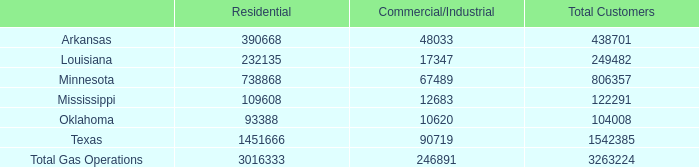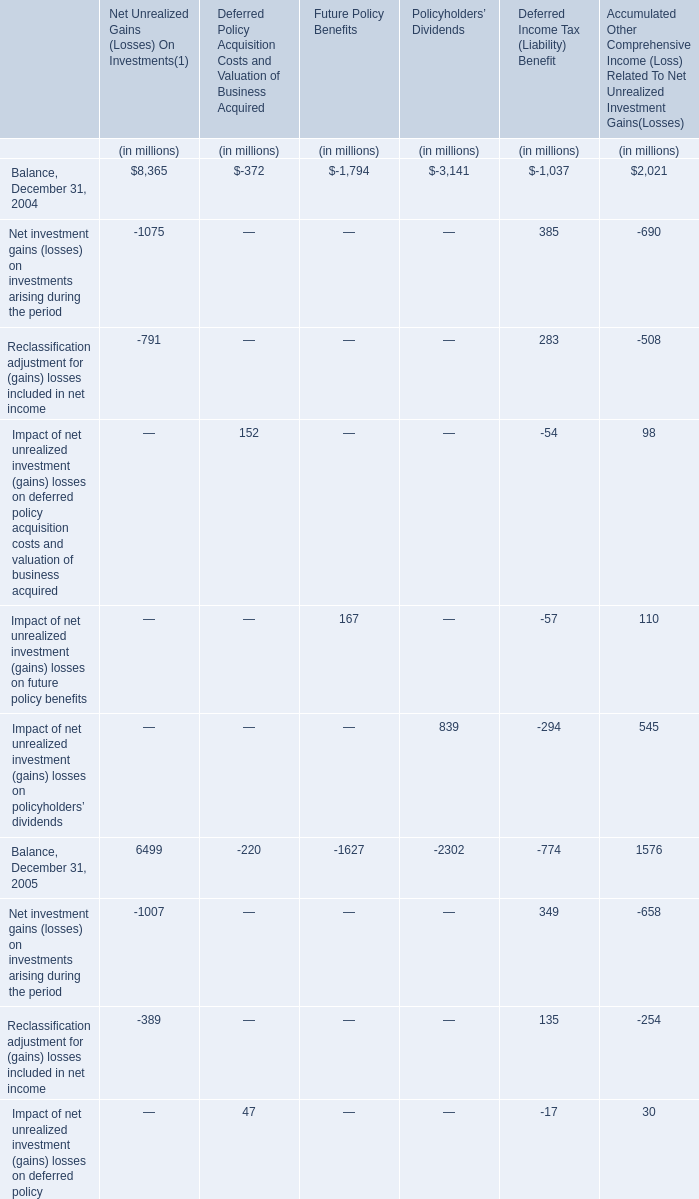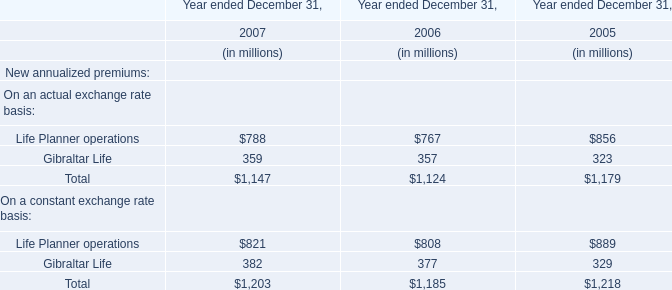what is the highest total amount of Balance, December 31, 2004? (in million) 
Answer: 8365. 